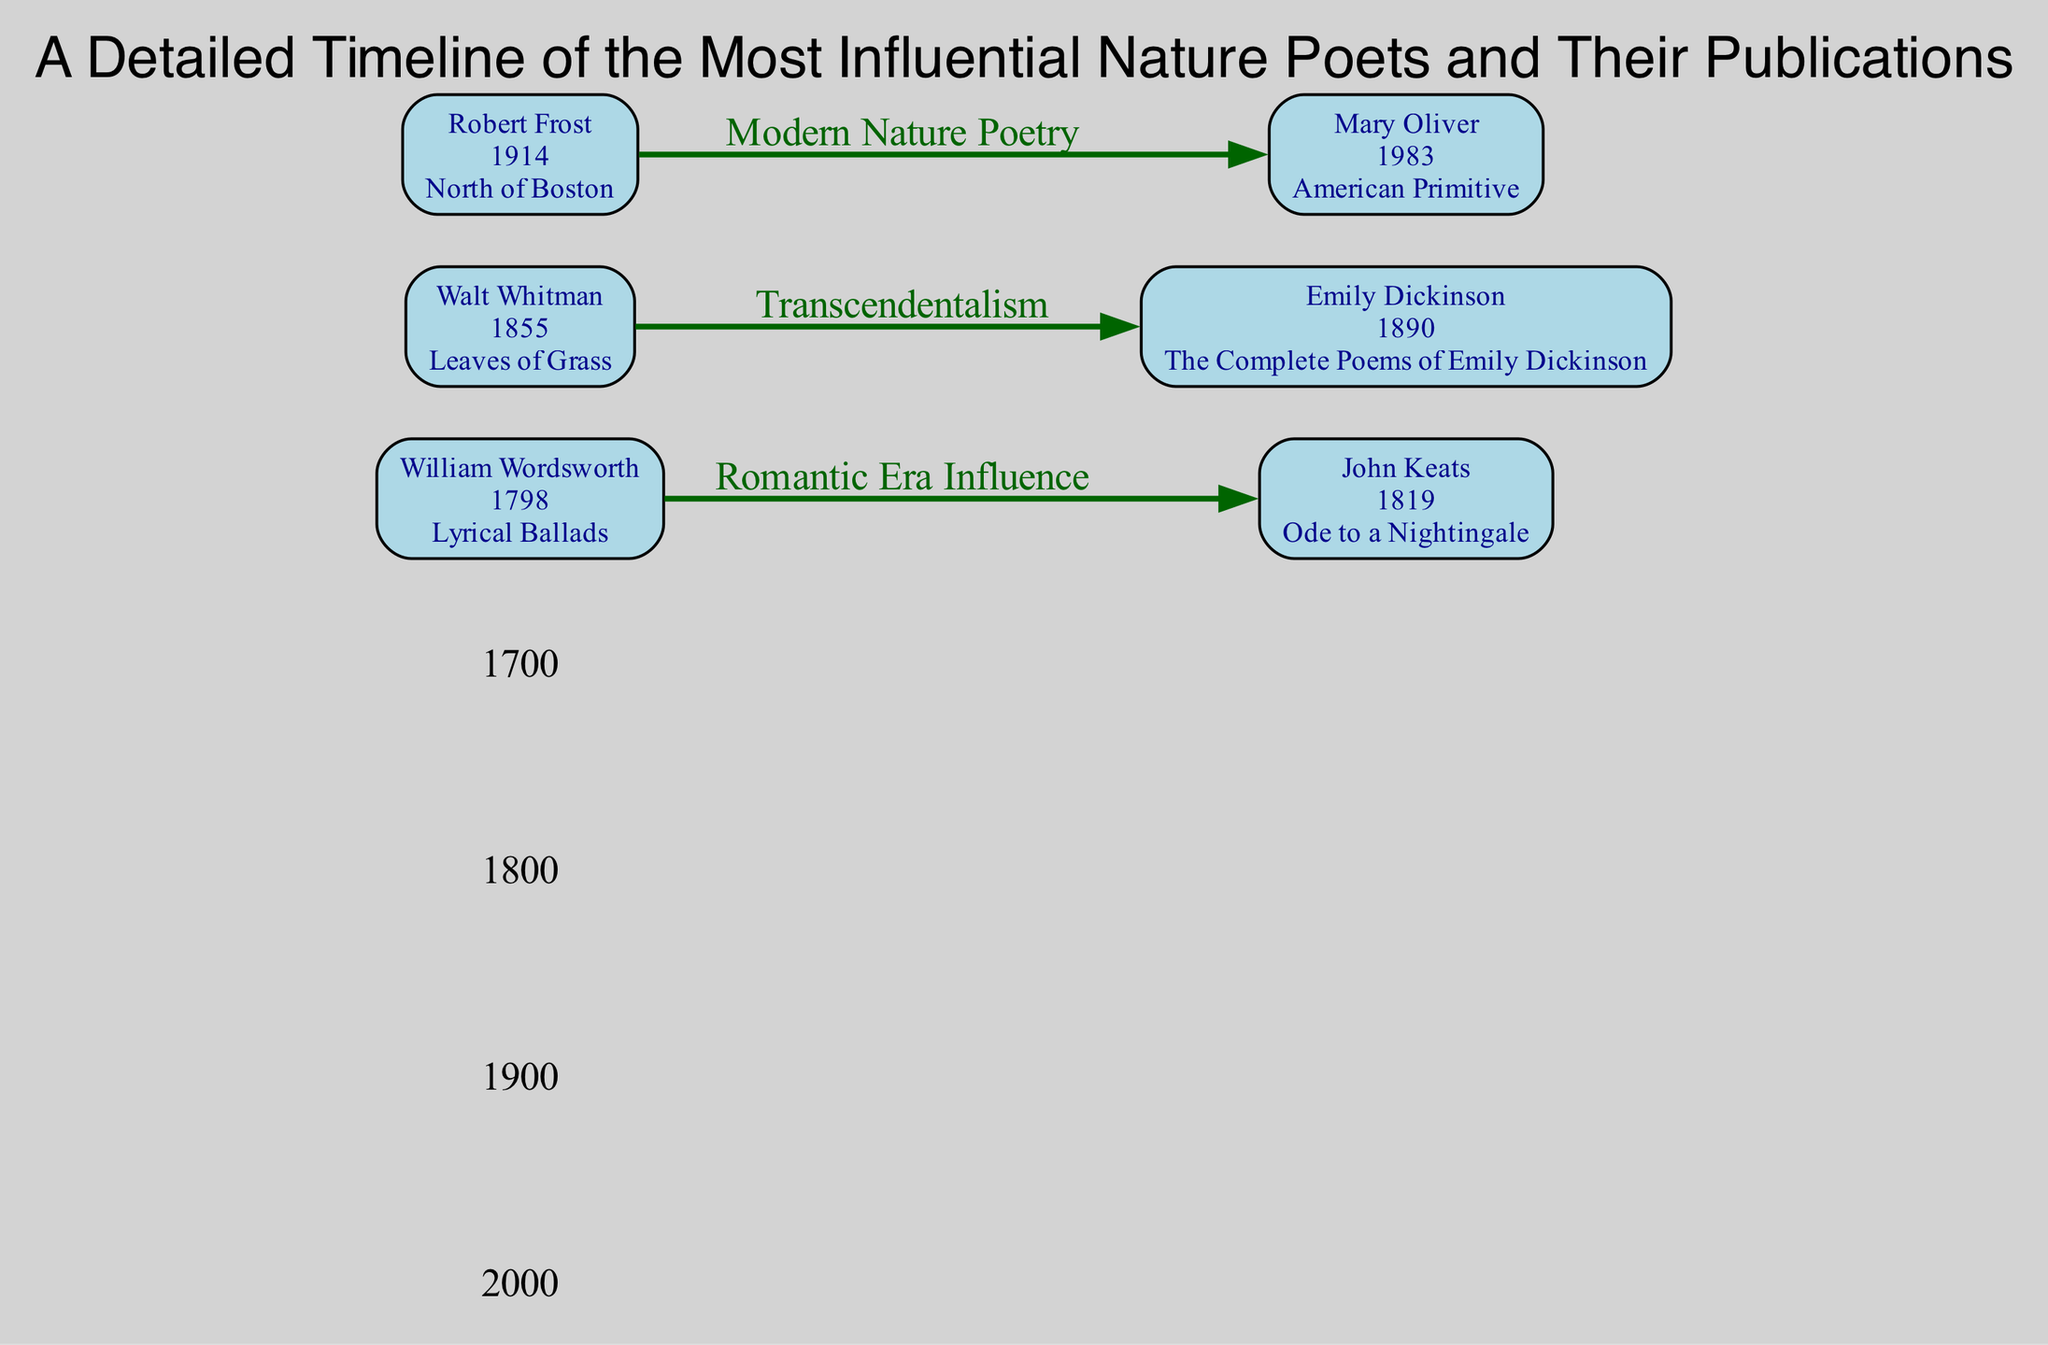What is the publication year of "Leaves of Grass"? The diagram shows that Walt Whitman published "Leaves of Grass" in 1855, as indicated next to his name.
Answer: 1855 Who wrote "The Complete Poems of Emily Dickinson"? The diagram clearly labels Emily Dickinson as the author of "The Complete Poems of Emily Dickinson", as seen in her node.
Answer: Emily Dickinson How many poets are listed in the diagram? By counting the nodes in the diagram, we find there are six poets included: William Wordsworth, John Keats, Walt Whitman, Emily Dickinson, Robert Frost, and Mary Oliver.
Answer: 6 What thematic influence is shown between Robert Frost and Mary Oliver? The diagram indicates a relationship labeled "Modern Nature Poetry" between the two poets, which connects their work chronologically and thematically.
Answer: Modern Nature Poetry Which poet's publication is linked to the Romantic Era influence? The diagram shows that John Keats is directly connected to William Wordsworth by an edge labeled "Romantic Era Influence", signifying the thematic connection between their works.
Answer: John Keats What is the earliest publication displayed on the timeline? Examining the nodes in the diagram, "Lyrical Ballads", published in 1798 by William Wordsworth, is the earliest work represented on the timeline.
Answer: Lyrical Ballads Which year marks the publication of "North of Boston"? The diagram specifies that "North of Boston" was published by Robert Frost in 1914, as shown in his node.
Answer: 1914 How does the theme of Transcendentalism connect Walt Whitman and Emily Dickinson? The diagram illustrates an edge labeled "Transcendentalism" connecting Walt Whitman and Emily Dickinson, indicating their works share this philosophical influence.
Answer: Transcendentalism What is the latest publication listed in the diagram? The diagram shows that Mary Oliver's "American Primitive" was published in 1983, making it the most recent work represented.
Answer: American Primitive 